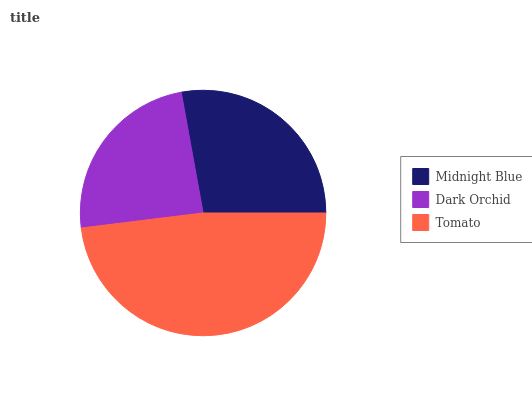Is Dark Orchid the minimum?
Answer yes or no. Yes. Is Tomato the maximum?
Answer yes or no. Yes. Is Tomato the minimum?
Answer yes or no. No. Is Dark Orchid the maximum?
Answer yes or no. No. Is Tomato greater than Dark Orchid?
Answer yes or no. Yes. Is Dark Orchid less than Tomato?
Answer yes or no. Yes. Is Dark Orchid greater than Tomato?
Answer yes or no. No. Is Tomato less than Dark Orchid?
Answer yes or no. No. Is Midnight Blue the high median?
Answer yes or no. Yes. Is Midnight Blue the low median?
Answer yes or no. Yes. Is Tomato the high median?
Answer yes or no. No. Is Dark Orchid the low median?
Answer yes or no. No. 